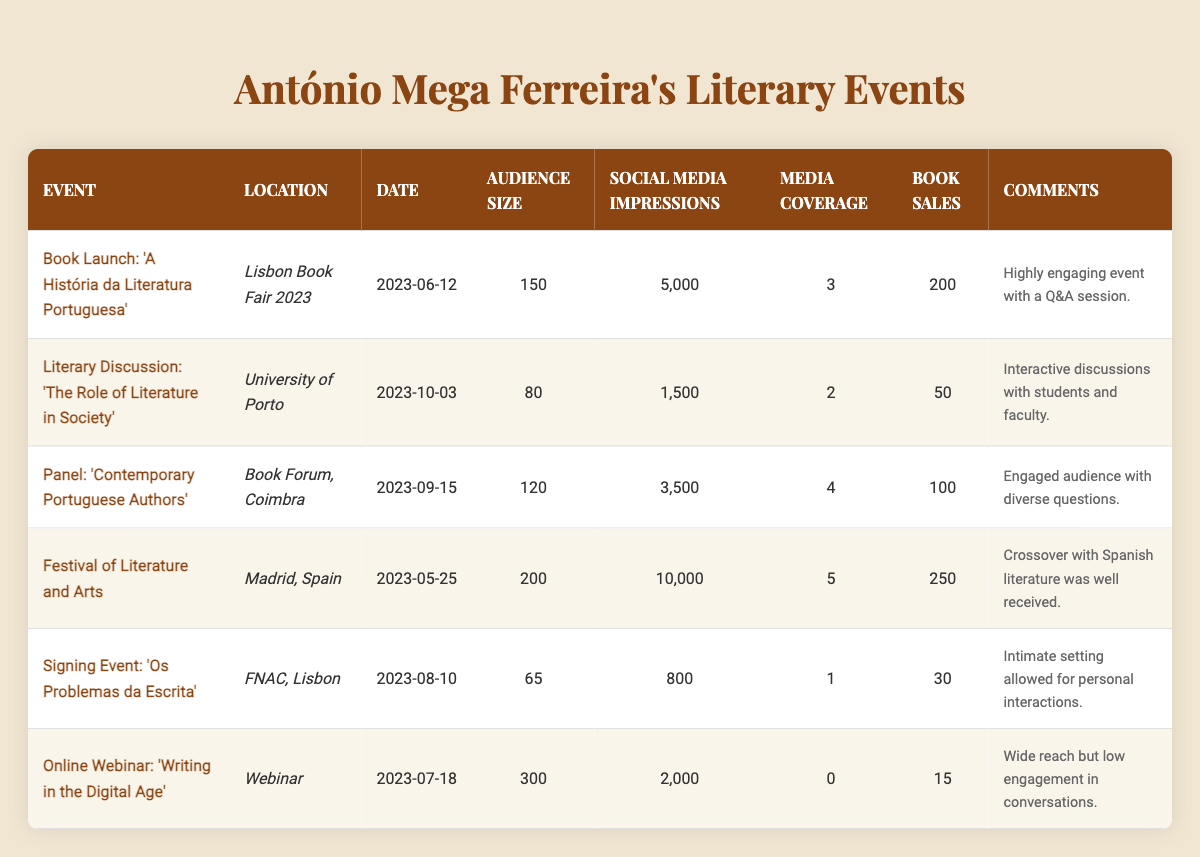What was the audience size for the event "Book Launch: 'A História da Literatura Portuguesa'"? The audience size for the event is listed directly in the table under the column "Audience Size" for that specific event, which shows a value of 150.
Answer: 150 How many social media impressions did the "Festival of Literature and Arts" receive? The table indicates the number of social media impressions directly under the relevant event, and it shows a total of 10,000 impressions.
Answer: 10,000 Which event had the highest book sales, and how many were sold? By reviewing the "Book Sales" column, the "Festival of Literature and Arts" has the highest sales at 250.
Answer: Festival of Literature and Arts, 250 What was the total number of social media impressions across all events? To find the total impressions, we sum the social media impressions from all events: 5000 + 1500 + 3500 + 10000 + 800 + 2000 = 22700.
Answer: 22700 On which date did the event with the lowest audience size occur? The table shows that the event "Signing Event: 'Os Problemas da Escrita'" had the lowest audience size of 65, and it occurred on "2023-08-10".
Answer: 2023-08-10 Did any event have zero media coverage? The event "Online Webinar: 'Writing in the Digital Age'" is listed with 0 media coverage in the "Media Coverage" column, indicating that yes, there was an event with zero media coverage.
Answer: Yes What is the average audience size across all events? First, sum the audience sizes: 150 + 80 + 120 + 200 + 65 + 300 = 915. Then, divide by the number of events (6): 915 / 6 = 152.5.
Answer: 152.5 Which event took place most recently? The most recent date is "2023-10-03" for the event "Literary Discussion: 'The Role of Literature in Society'", according to the date column that lists all events chronologically.
Answer: Literary Discussion: 'The Role of Literature in Society' What is the difference in book sales between the "Online Webinar: 'Writing in the Digital Age'" and the "Panel: 'Contemporary Portuguese Authors'"? The book sales for the webinar is 15 and for the panel is 100; thus, the difference is 100 - 15 = 85.
Answer: 85 Was the "Signing Event: 'Os Problemas da Escrita'" considered highly engaging? According to the comments in the table, the "Signing Event: 'Os Problemas da Escrita'" was described as an "intimate setting allowed for personal interactions," which does not indicate high engagement compared to the Q&A session noted for the launch event.
Answer: No 